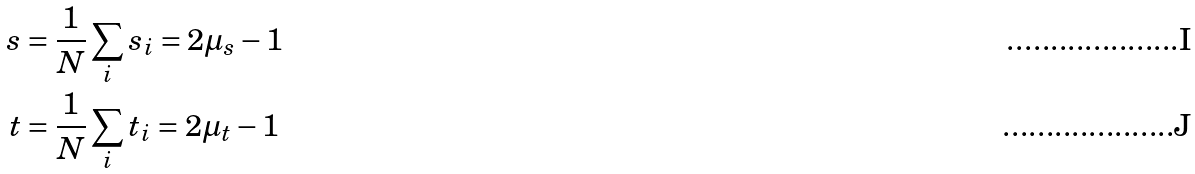<formula> <loc_0><loc_0><loc_500><loc_500>s & = \frac { 1 } { N } \sum _ { i } s _ { i } = 2 \mu _ { s } - 1 \\ t & = \frac { 1 } { N } \sum _ { i } t _ { i } = 2 \mu _ { t } - 1</formula> 